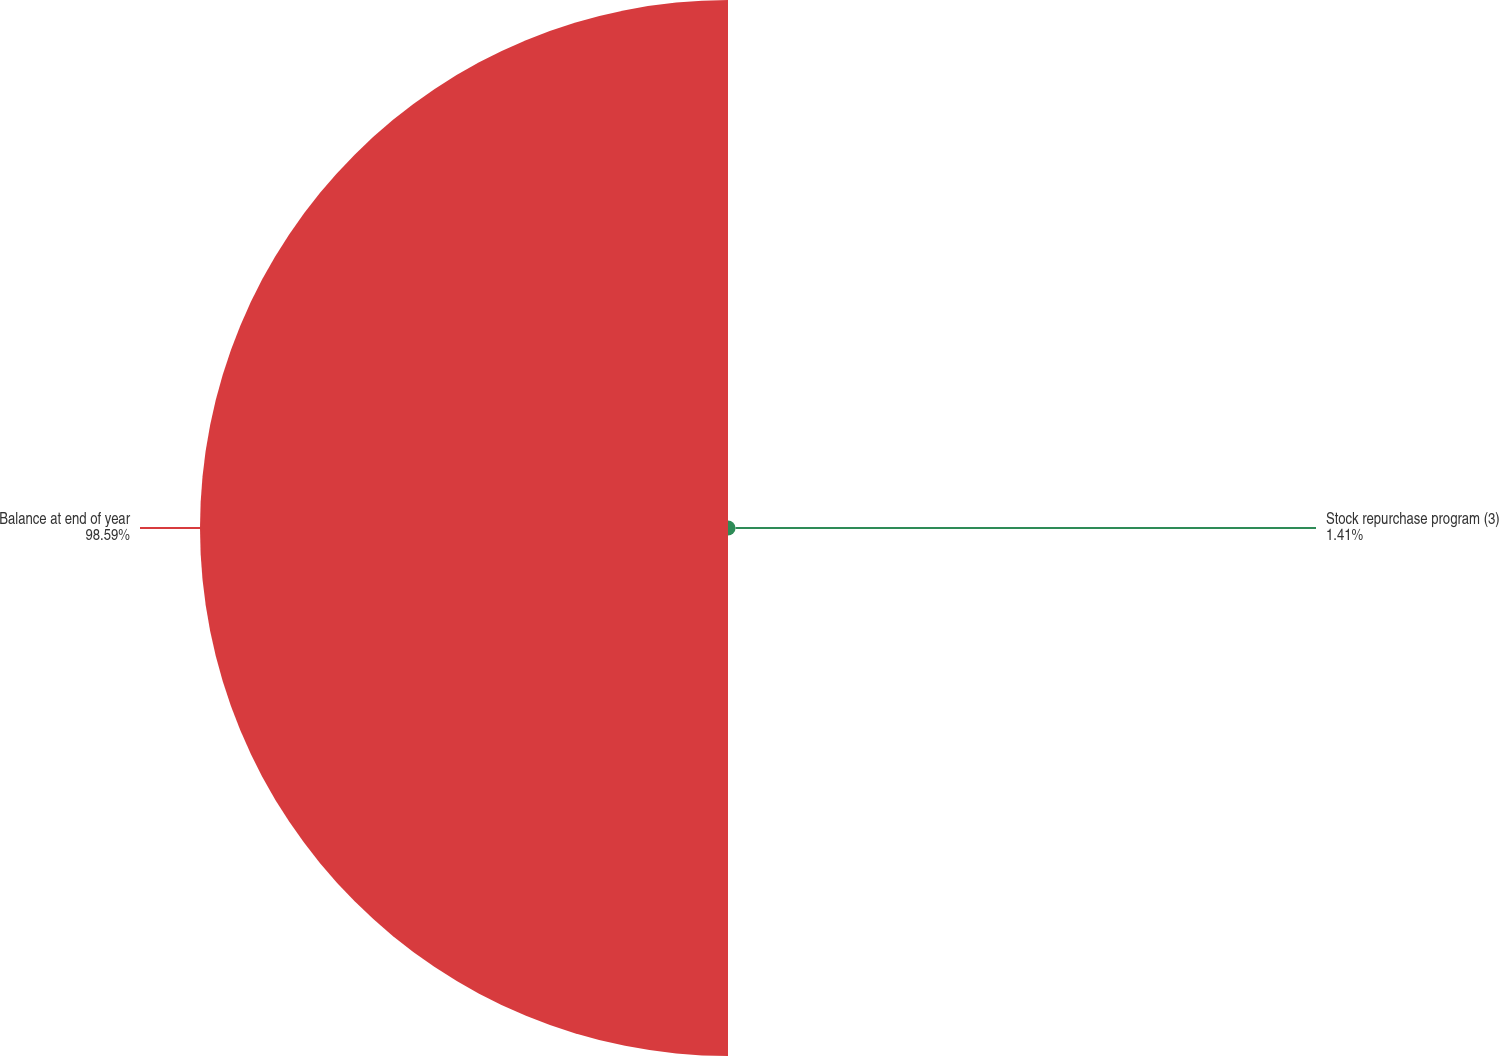Convert chart to OTSL. <chart><loc_0><loc_0><loc_500><loc_500><pie_chart><fcel>Stock repurchase program (3)<fcel>Balance at end of year<nl><fcel>1.41%<fcel>98.59%<nl></chart> 